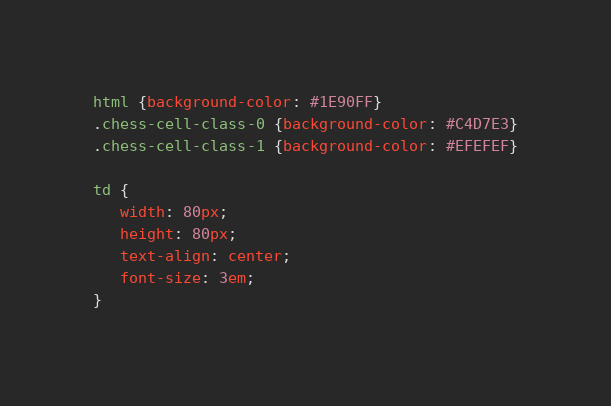Convert code to text. <code><loc_0><loc_0><loc_500><loc_500><_CSS_>html {background-color: #1E90FF}
.chess-cell-class-0 {background-color: #C4D7E3}
.chess-cell-class-1 {background-color: #EFEFEF}

td {
   width: 80px;
   height: 80px;
   text-align: center;
   font-size: 3em;
}
</code> 